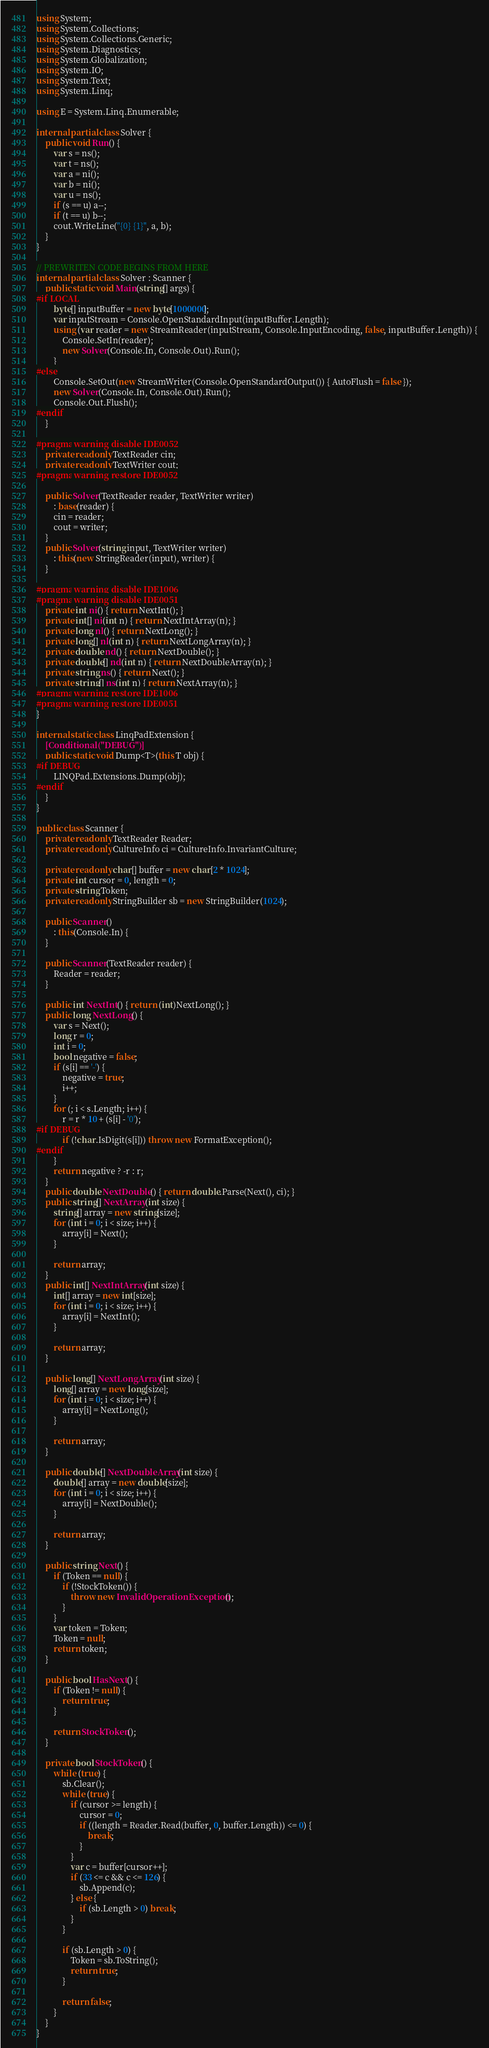<code> <loc_0><loc_0><loc_500><loc_500><_C#_>using System;
using System.Collections;
using System.Collections.Generic;
using System.Diagnostics;
using System.Globalization;
using System.IO;
using System.Text;
using System.Linq;

using E = System.Linq.Enumerable;

internal partial class Solver {
    public void Run() {
        var s = ns();
        var t = ns();
        var a = ni();
        var b = ni();
        var u = ns();
        if (s == u) a--;
        if (t == u) b--;
        cout.WriteLine("{0} {1}", a, b);
    }
}

// PREWRITEN CODE BEGINS FROM HERE
internal partial class Solver : Scanner {
    public static void Main(string[] args) {
#if LOCAL
        byte[] inputBuffer = new byte[1000000];
        var inputStream = Console.OpenStandardInput(inputBuffer.Length);
        using (var reader = new StreamReader(inputStream, Console.InputEncoding, false, inputBuffer.Length)) {
            Console.SetIn(reader);
            new Solver(Console.In, Console.Out).Run();
        }
#else
        Console.SetOut(new StreamWriter(Console.OpenStandardOutput()) { AutoFlush = false });
        new Solver(Console.In, Console.Out).Run();
        Console.Out.Flush();
#endif
    }

#pragma warning disable IDE0052
    private readonly TextReader cin;
    private readonly TextWriter cout;
#pragma warning restore IDE0052

    public Solver(TextReader reader, TextWriter writer)
        : base(reader) {
        cin = reader;
        cout = writer;
    }
    public Solver(string input, TextWriter writer)
        : this(new StringReader(input), writer) {
    }

#pragma warning disable IDE1006
#pragma warning disable IDE0051
    private int ni() { return NextInt(); }
    private int[] ni(int n) { return NextIntArray(n); }
    private long nl() { return NextLong(); }
    private long[] nl(int n) { return NextLongArray(n); }
    private double nd() { return NextDouble(); }
    private double[] nd(int n) { return NextDoubleArray(n); }
    private string ns() { return Next(); }
    private string[] ns(int n) { return NextArray(n); }
#pragma warning restore IDE1006
#pragma warning restore IDE0051
}

internal static class LinqPadExtension {
    [Conditional("DEBUG")]
    public static void Dump<T>(this T obj) {
#if DEBUG
        LINQPad.Extensions.Dump(obj);
#endif
    }
}

public class Scanner {
    private readonly TextReader Reader;
    private readonly CultureInfo ci = CultureInfo.InvariantCulture;

    private readonly char[] buffer = new char[2 * 1024];
    private int cursor = 0, length = 0;
    private string Token;
    private readonly StringBuilder sb = new StringBuilder(1024);

    public Scanner()
        : this(Console.In) {
    }

    public Scanner(TextReader reader) {
        Reader = reader;
    }

    public int NextInt() { return (int)NextLong(); }
    public long NextLong() {
        var s = Next();
        long r = 0;
        int i = 0;
        bool negative = false;
        if (s[i] == '-') {
            negative = true;
            i++;
        }
        for (; i < s.Length; i++) {
            r = r * 10 + (s[i] - '0');
#if DEBUG
            if (!char.IsDigit(s[i])) throw new FormatException();
#endif
        }
        return negative ? -r : r;
    }
    public double NextDouble() { return double.Parse(Next(), ci); }
    public string[] NextArray(int size) {
        string[] array = new string[size];
        for (int i = 0; i < size; i++) {
            array[i] = Next();
        }

        return array;
    }
    public int[] NextIntArray(int size) {
        int[] array = new int[size];
        for (int i = 0; i < size; i++) {
            array[i] = NextInt();
        }

        return array;
    }

    public long[] NextLongArray(int size) {
        long[] array = new long[size];
        for (int i = 0; i < size; i++) {
            array[i] = NextLong();
        }

        return array;
    }

    public double[] NextDoubleArray(int size) {
        double[] array = new double[size];
        for (int i = 0; i < size; i++) {
            array[i] = NextDouble();
        }

        return array;
    }

    public string Next() {
        if (Token == null) {
            if (!StockToken()) {
                throw new InvalidOperationException();
            }
        }
        var token = Token;
        Token = null;
        return token;
    }

    public bool HasNext() {
        if (Token != null) {
            return true;
        }

        return StockToken();
    }

    private bool StockToken() {
        while (true) {
            sb.Clear();
            while (true) {
                if (cursor >= length) {
                    cursor = 0;
                    if ((length = Reader.Read(buffer, 0, buffer.Length)) <= 0) {
                        break;
                    }
                }
                var c = buffer[cursor++];
                if (33 <= c && c <= 126) {
                    sb.Append(c);
                } else {
                    if (sb.Length > 0) break;
                }
            }

            if (sb.Length > 0) {
                Token = sb.ToString();
                return true;
            }

            return false;
        }
    }
}</code> 